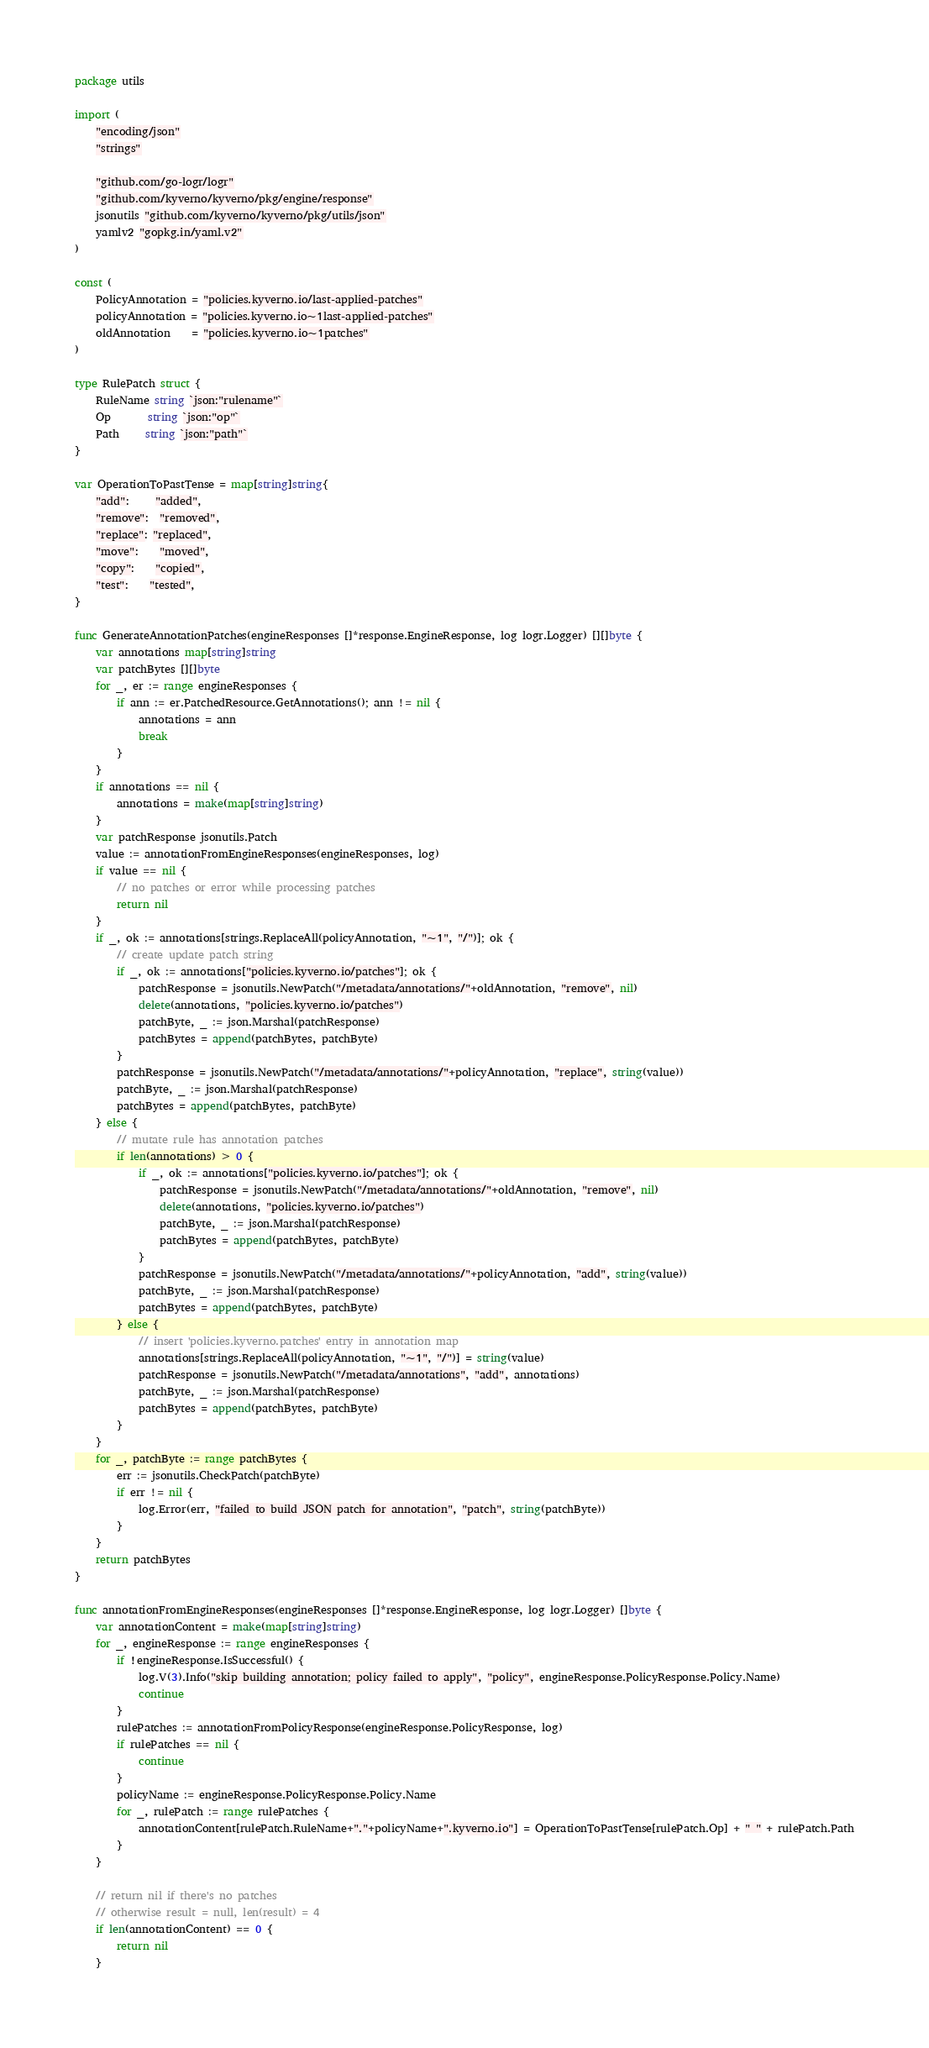Convert code to text. <code><loc_0><loc_0><loc_500><loc_500><_Go_>package utils

import (
	"encoding/json"
	"strings"

	"github.com/go-logr/logr"
	"github.com/kyverno/kyverno/pkg/engine/response"
	jsonutils "github.com/kyverno/kyverno/pkg/utils/json"
	yamlv2 "gopkg.in/yaml.v2"
)

const (
	PolicyAnnotation = "policies.kyverno.io/last-applied-patches"
	policyAnnotation = "policies.kyverno.io~1last-applied-patches"
	oldAnnotation    = "policies.kyverno.io~1patches"
)

type RulePatch struct {
	RuleName string `json:"rulename"`
	Op       string `json:"op"`
	Path     string `json:"path"`
}

var OperationToPastTense = map[string]string{
	"add":     "added",
	"remove":  "removed",
	"replace": "replaced",
	"move":    "moved",
	"copy":    "copied",
	"test":    "tested",
}

func GenerateAnnotationPatches(engineResponses []*response.EngineResponse, log logr.Logger) [][]byte {
	var annotations map[string]string
	var patchBytes [][]byte
	for _, er := range engineResponses {
		if ann := er.PatchedResource.GetAnnotations(); ann != nil {
			annotations = ann
			break
		}
	}
	if annotations == nil {
		annotations = make(map[string]string)
	}
	var patchResponse jsonutils.Patch
	value := annotationFromEngineResponses(engineResponses, log)
	if value == nil {
		// no patches or error while processing patches
		return nil
	}
	if _, ok := annotations[strings.ReplaceAll(policyAnnotation, "~1", "/")]; ok {
		// create update patch string
		if _, ok := annotations["policies.kyverno.io/patches"]; ok {
			patchResponse = jsonutils.NewPatch("/metadata/annotations/"+oldAnnotation, "remove", nil)
			delete(annotations, "policies.kyverno.io/patches")
			patchByte, _ := json.Marshal(patchResponse)
			patchBytes = append(patchBytes, patchByte)
		}
		patchResponse = jsonutils.NewPatch("/metadata/annotations/"+policyAnnotation, "replace", string(value))
		patchByte, _ := json.Marshal(patchResponse)
		patchBytes = append(patchBytes, patchByte)
	} else {
		// mutate rule has annotation patches
		if len(annotations) > 0 {
			if _, ok := annotations["policies.kyverno.io/patches"]; ok {
				patchResponse = jsonutils.NewPatch("/metadata/annotations/"+oldAnnotation, "remove", nil)
				delete(annotations, "policies.kyverno.io/patches")
				patchByte, _ := json.Marshal(patchResponse)
				patchBytes = append(patchBytes, patchByte)
			}
			patchResponse = jsonutils.NewPatch("/metadata/annotations/"+policyAnnotation, "add", string(value))
			patchByte, _ := json.Marshal(patchResponse)
			patchBytes = append(patchBytes, patchByte)
		} else {
			// insert 'policies.kyverno.patches' entry in annotation map
			annotations[strings.ReplaceAll(policyAnnotation, "~1", "/")] = string(value)
			patchResponse = jsonutils.NewPatch("/metadata/annotations", "add", annotations)
			patchByte, _ := json.Marshal(patchResponse)
			patchBytes = append(patchBytes, patchByte)
		}
	}
	for _, patchByte := range patchBytes {
		err := jsonutils.CheckPatch(patchByte)
		if err != nil {
			log.Error(err, "failed to build JSON patch for annotation", "patch", string(patchByte))
		}
	}
	return patchBytes
}

func annotationFromEngineResponses(engineResponses []*response.EngineResponse, log logr.Logger) []byte {
	var annotationContent = make(map[string]string)
	for _, engineResponse := range engineResponses {
		if !engineResponse.IsSuccessful() {
			log.V(3).Info("skip building annotation; policy failed to apply", "policy", engineResponse.PolicyResponse.Policy.Name)
			continue
		}
		rulePatches := annotationFromPolicyResponse(engineResponse.PolicyResponse, log)
		if rulePatches == nil {
			continue
		}
		policyName := engineResponse.PolicyResponse.Policy.Name
		for _, rulePatch := range rulePatches {
			annotationContent[rulePatch.RuleName+"."+policyName+".kyverno.io"] = OperationToPastTense[rulePatch.Op] + " " + rulePatch.Path
		}
	}

	// return nil if there's no patches
	// otherwise result = null, len(result) = 4
	if len(annotationContent) == 0 {
		return nil
	}
</code> 